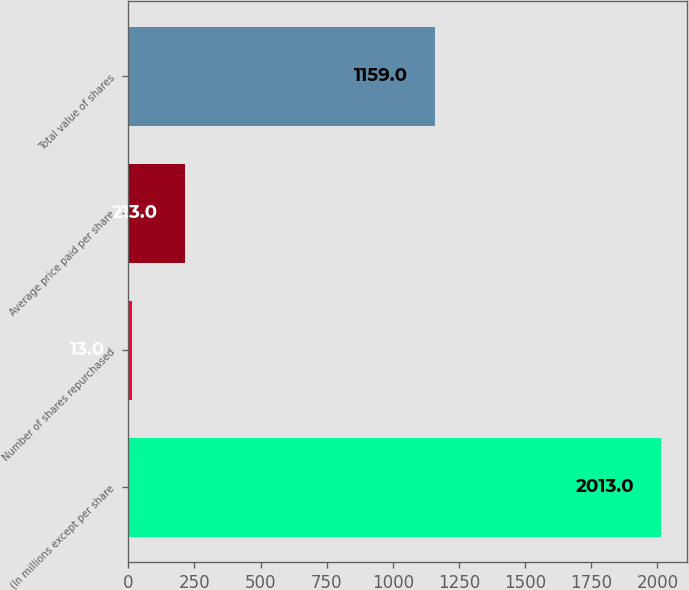Convert chart. <chart><loc_0><loc_0><loc_500><loc_500><bar_chart><fcel>(In millions except per share<fcel>Number of shares repurchased<fcel>Average price paid per share<fcel>Total value of shares<nl><fcel>2013<fcel>13<fcel>213<fcel>1159<nl></chart> 